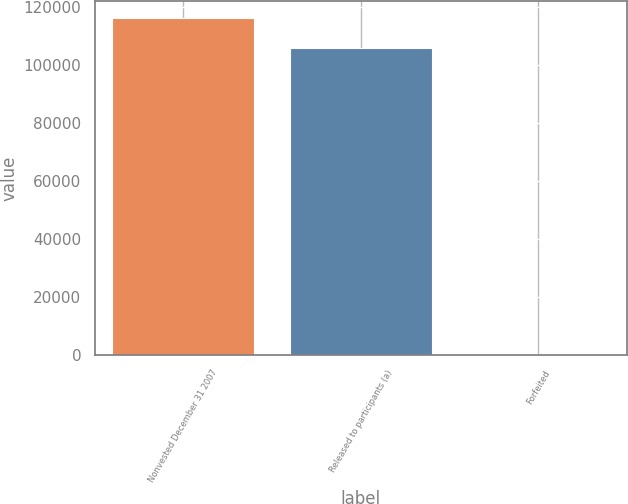<chart> <loc_0><loc_0><loc_500><loc_500><bar_chart><fcel>Nonvested December 31 2007<fcel>Released to participants (a)<fcel>Forfeited<nl><fcel>116334<fcel>105758<fcel>381<nl></chart> 